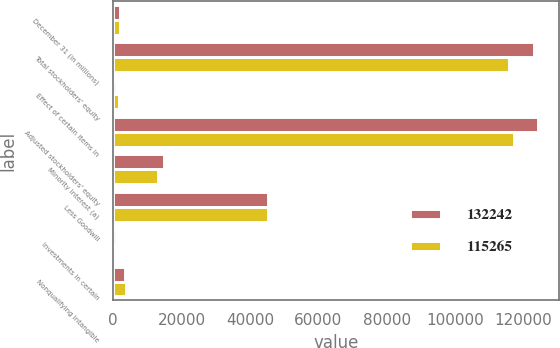<chart> <loc_0><loc_0><loc_500><loc_500><stacked_bar_chart><ecel><fcel>December 31 (in millions)<fcel>Total stockholders' equity<fcel>Effect of certain items in<fcel>Adjusted stockholders' equity<fcel>Minority interest (a)<fcel>Less Goodwill<fcel>Investments in certain<fcel>Nonqualifying intangible<nl><fcel>132242<fcel>2007<fcel>123221<fcel>925<fcel>124146<fcel>15005<fcel>45270<fcel>782<fcel>3471<nl><fcel>115265<fcel>2006<fcel>115790<fcel>1562<fcel>117352<fcel>12970<fcel>45186<fcel>420<fcel>3661<nl></chart> 